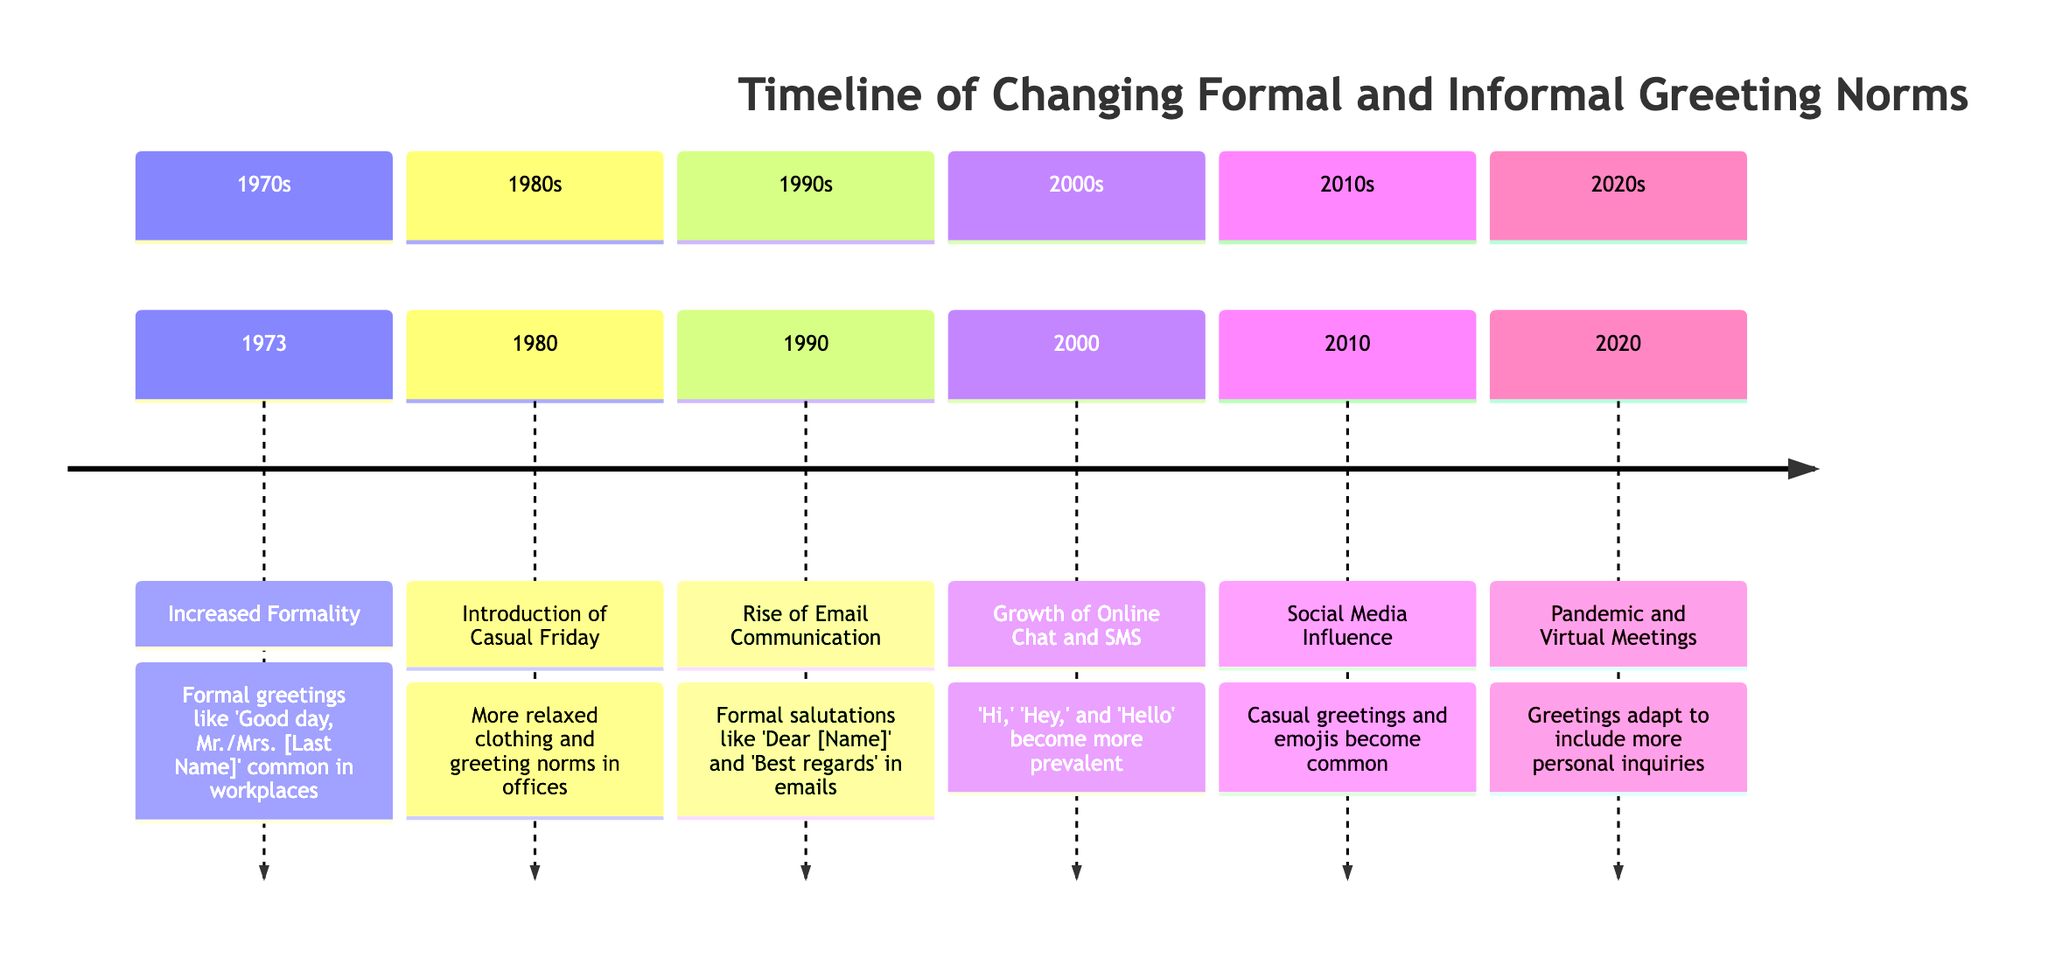What year marked the introduction of Casual Friday? Looking at the timeline, the event "Introduction of Casual Friday" is listed under the year 1980.
Answer: 1980 What greeting style became common in the 1970s? In the section for the 1970s, the event "Increased Formality" mentions that formal greetings like 'Good day, Mr./Mrs. [Last Name]' were common during that time.
Answer: Formal greetings What event is associated with the year 1990? The timeline lists "Rise of Email Communication" as the event for the year 1990.
Answer: Rise of Email Communication Which greeting style became more prevalent with online chat and SMS? In the 2000s section, it states that greetings like 'Hi,' 'Hey,' and 'Hello' became more prevalent.
Answer: 'Hi,' 'Hey,' and 'Hello' How did the COVID-19 pandemic influence greetings? The section for 2020 explains that the pandemic caused greetings to adapt to include personal inquiries such as 'How are you holding up?'.
Answer: Personal inquiries What significant shift in greetings happened in the 2010s? In the 2010 section, it mentions that social media influenced greetings to become more casual and abbreviated, with emojis becoming common.
Answer: Casual and abbreviated Which two events marked the transition from formal to informal greetings in the timeline? Reviewing the events sequentially, "Increased Formality" in 1973 and "Introduction of Casual Friday" in 1980 indicate a shift towards informality.
Answer: Increased Formality and Introduction of Casual Friday How many sections are there in the timeline? Counting the distinct sections listed in the timeline, we see sections for the 1970s, 1980s, 1990s, 2000s, 2010s, and 2020s—a total of six sections.
Answer: 6 Which year saw a significant influence from social media on greetings? The event in the year 2010 indicates that social media had a substantial influence on greeting norms.
Answer: 2010 